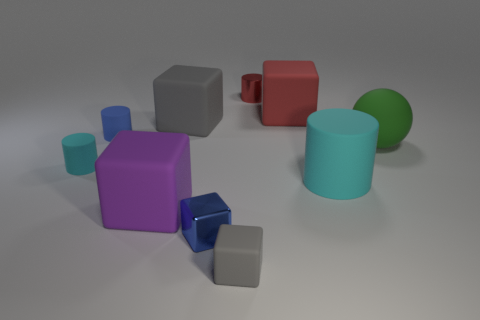What size is the red rubber thing that is the same shape as the purple matte object?
Keep it short and to the point. Large. Are there any other things that have the same size as the red rubber thing?
Make the answer very short. Yes. Does the metal block have the same size as the red object on the left side of the red block?
Your response must be concise. Yes. There is a gray thing in front of the big gray rubber object; what is its shape?
Give a very brief answer. Cube. The big ball behind the tiny cylinder in front of the large ball is what color?
Keep it short and to the point. Green. There is another large object that is the same shape as the red metal thing; what color is it?
Provide a short and direct response. Cyan. How many rubber objects are the same color as the large ball?
Provide a short and direct response. 0. Is the color of the tiny matte cube the same as the big rubber cube that is in front of the big green object?
Provide a succinct answer. No. The big rubber object that is behind the big matte cylinder and left of the red metallic cylinder has what shape?
Offer a very short reply. Cube. There is a block that is right of the small cylinder that is behind the red thing on the right side of the red metal object; what is its material?
Your answer should be compact. Rubber. 